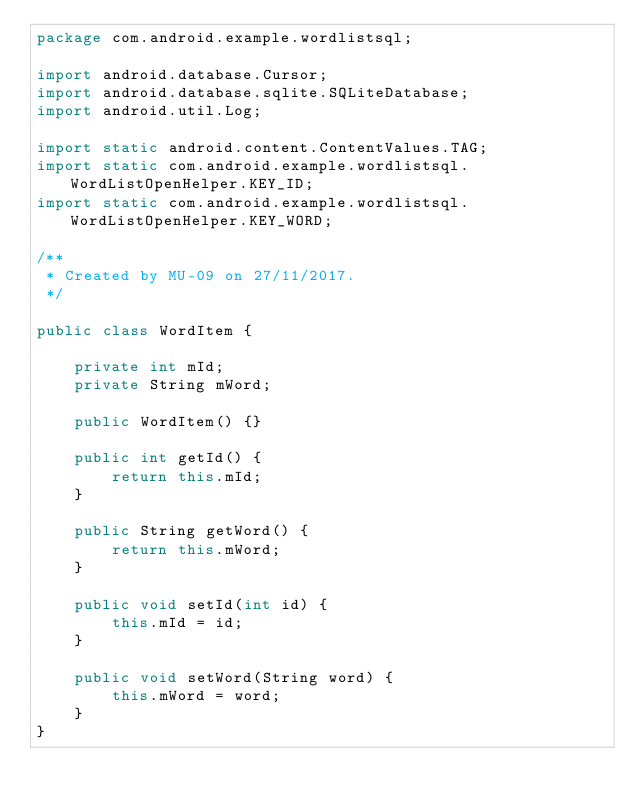Convert code to text. <code><loc_0><loc_0><loc_500><loc_500><_Java_>package com.android.example.wordlistsql;

import android.database.Cursor;
import android.database.sqlite.SQLiteDatabase;
import android.util.Log;

import static android.content.ContentValues.TAG;
import static com.android.example.wordlistsql.WordListOpenHelper.KEY_ID;
import static com.android.example.wordlistsql.WordListOpenHelper.KEY_WORD;

/**
 * Created by MU-09 on 27/11/2017.
 */

public class WordItem {

    private int mId;
    private String mWord;

    public WordItem() {}

    public int getId() {
        return this.mId;
    }

    public String getWord() {
        return this.mWord;
    }

    public void setId(int id) {
        this.mId = id;
    }

    public void setWord(String word) {
        this.mWord = word;
    }
}
</code> 